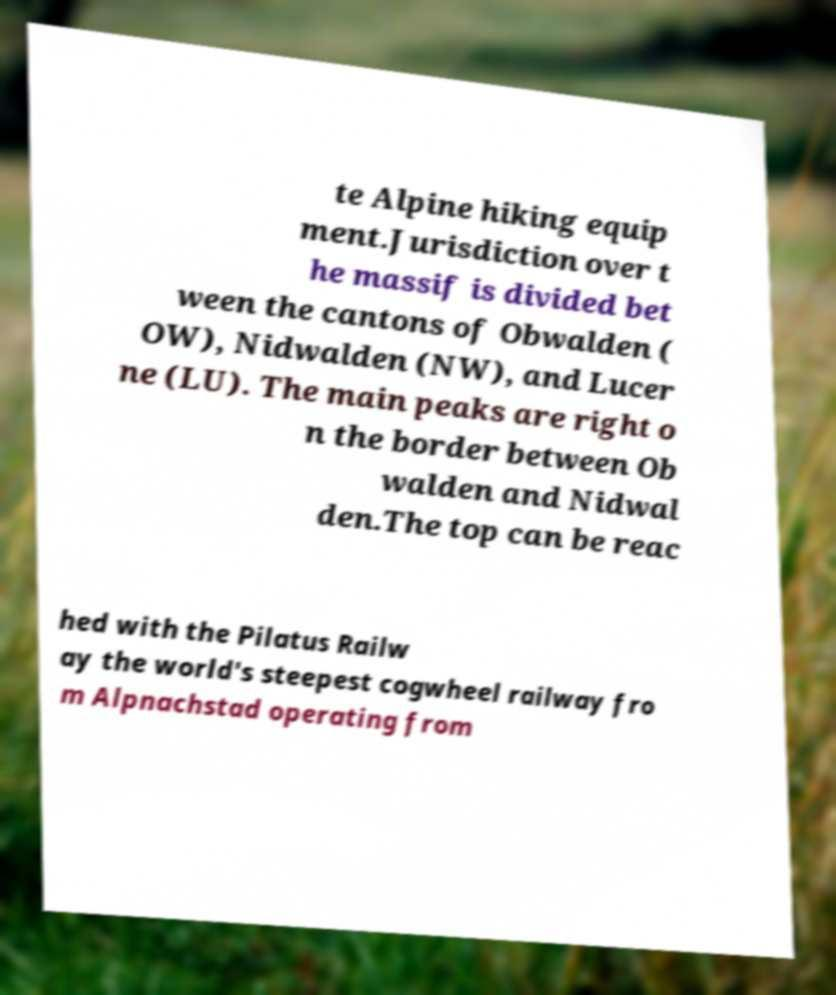Please read and relay the text visible in this image. What does it say? te Alpine hiking equip ment.Jurisdiction over t he massif is divided bet ween the cantons of Obwalden ( OW), Nidwalden (NW), and Lucer ne (LU). The main peaks are right o n the border between Ob walden and Nidwal den.The top can be reac hed with the Pilatus Railw ay the world's steepest cogwheel railway fro m Alpnachstad operating from 